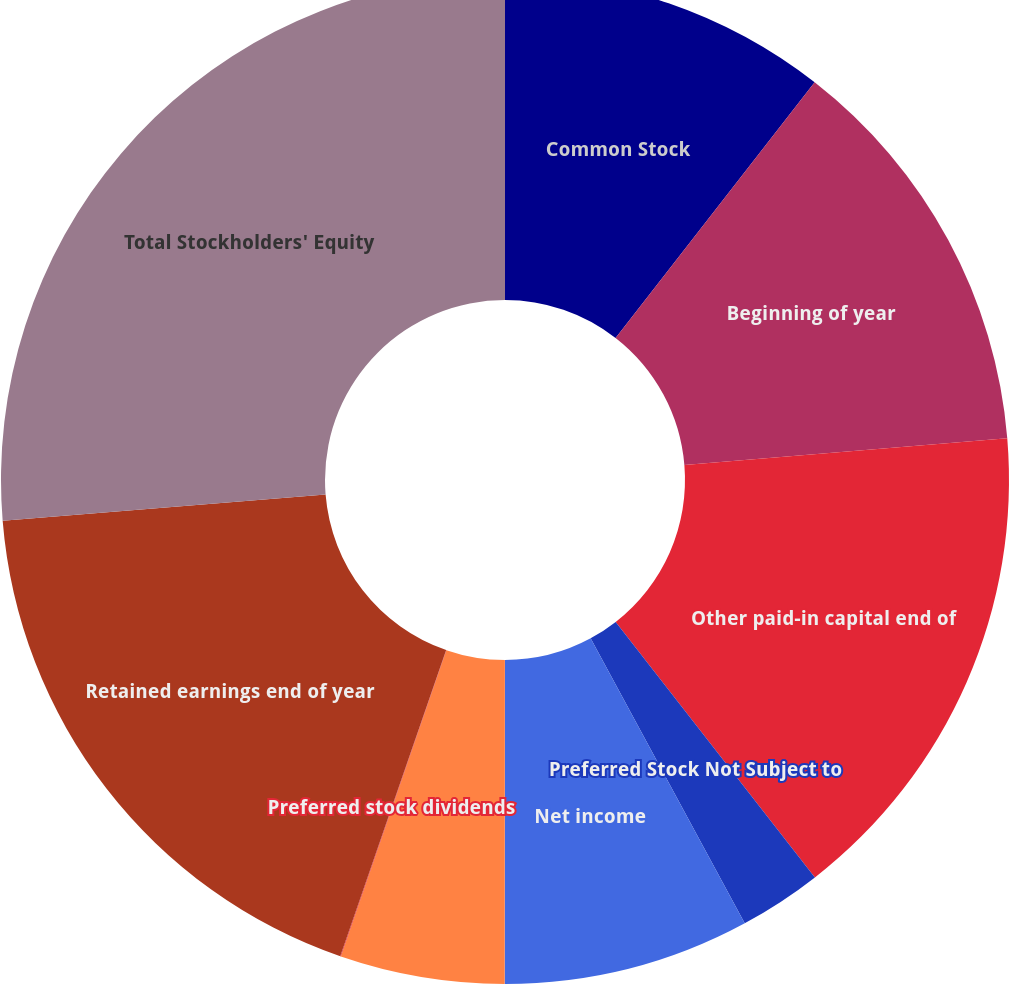Convert chart. <chart><loc_0><loc_0><loc_500><loc_500><pie_chart><fcel>Common Stock<fcel>Beginning of year<fcel>Other paid-in capital end of<fcel>Preferred Stock Not Subject to<fcel>Net income<fcel>Common stock dividends<fcel>Preferred stock dividends<fcel>Retained earnings end of year<fcel>Total Stockholders' Equity<nl><fcel>10.53%<fcel>13.15%<fcel>15.78%<fcel>2.65%<fcel>7.9%<fcel>5.27%<fcel>0.02%<fcel>18.41%<fcel>26.29%<nl></chart> 